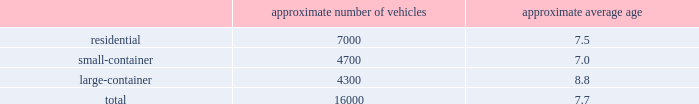Organizational structure a key enabler of the republic way operating model is our organizational structure that fosters a high performance culture by maintaining 360-degree accountability and full profit and loss responsibility with local management , supported by a functional structure to provide subject matter expertise .
This structure allows us to take advantage of our scale by coordinating functionally across all of our markets , while empowering local management to respond to unique market dynamics .
Our senior management evaluates , oversees and manages the financial performance of our operations through two field groups , referred to as group 1 and group 2 .
Group 1 primarily consists of geographic areas located in the western united states , and group 2 primarily consists of geographic areas located in the southeastern and mid-western united states , and the eastern seaboard of the united states .
Each field group is organized into several areas and each area contains multiple business units or operating locations .
Each of our field groups and all of our areas provide collection , transfer , recycling and landfill services .
See note 14 , segment reporting , to our consolidated financial statements in item 8 of this form 10-k for further discussion of our operating segments .
Through this operating model , we have rolled out several productivity and cost control initiatives designed to deliver the best service possible to our customers in an efficient and environmentally sound way .
Fleet automation approximately 75% ( 75 % ) of our residential routes have been converted to automated single-driver trucks .
By converting our residential routes to automated service , we reduce labor costs , improve driver productivity , decrease emissions and create a safer work environment for our employees .
Additionally , communities using automated vehicles have higher participation rates in recycling programs , thereby complementing our initiative to expand our recycling capabilities .
Fleet conversion to compressed natural gas ( cng ) approximately 20% ( 20 % ) of our fleet operates on natural gas .
We expect to continue our gradual fleet conversion to cng as part of our ordinary annual fleet replacement process .
We believe a gradual fleet conversion is the most prudent approach to realizing the full value of our previous fleet investments .
Approximately 13% ( 13 % ) of our replacement vehicle purchases during 2018 were cng vehicles .
We believe using cng vehicles provides us a competitive advantage in communities with strict clean emission initiatives that focus on protecting the environment .
Although upfront capital costs are higher , using cng reduces our overall fleet operating costs through lower fuel expenses .
As of december 31 , 2018 , we operated 37 cng fueling stations .
Standardized maintenance based on an industry trade publication , we operate the seventh largest vocational fleet in the united states .
As of december 31 , 2018 , our average fleet age in years , by line of business , was as follows : approximate number of vehicles approximate average age .
Onefleet , our standardized vehicle maintenance program , enables us to use best practices for fleet management , truck care and maintenance .
Through standardization of core functions , we believe we can minimize variability .
What is the ratio of the number of vehicles for the residential line of business to large-container? 
Rationale: the ratio of the number of cars for the residential line of business to large-container is 1.63 to 1
Computations: (7000 / 4300)
Answer: 1.62791. 